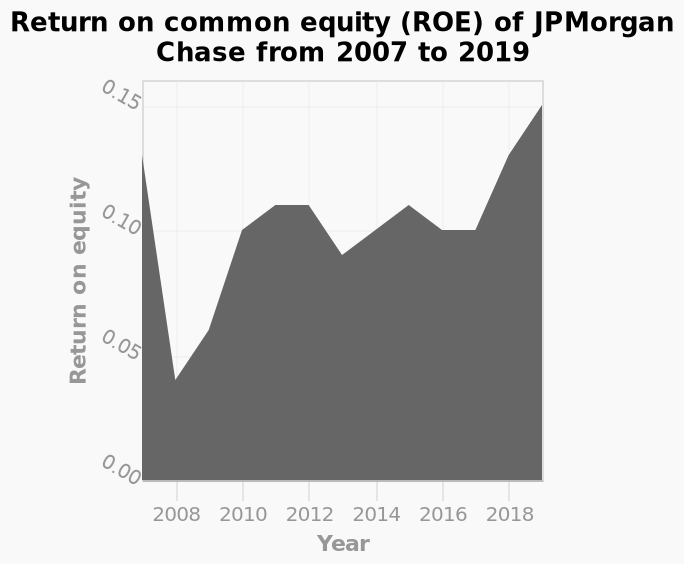<image>
What does the y-axis represent in the area chart?  The y-axis represents the Return on equity values ranging from 0.00 to 0.15. 